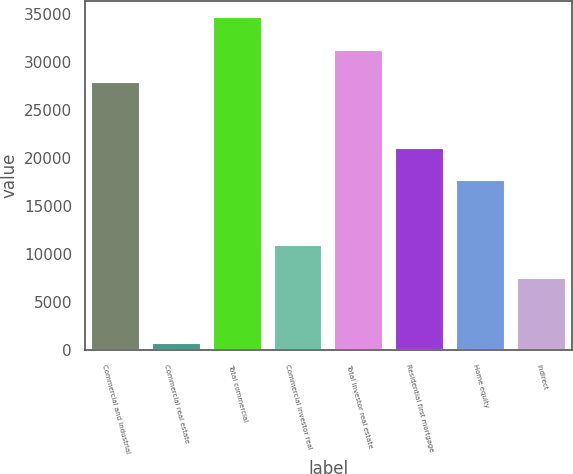<chart> <loc_0><loc_0><loc_500><loc_500><bar_chart><fcel>Commercial and industrial<fcel>Commercial real estate<fcel>Total commercial<fcel>Commercial investor real<fcel>Total investor real estate<fcel>Residential first mortgage<fcel>Home equity<fcel>Indirect<nl><fcel>27847.8<fcel>751<fcel>34622<fcel>10912.3<fcel>31234.9<fcel>21073.6<fcel>17686.5<fcel>7525.2<nl></chart> 